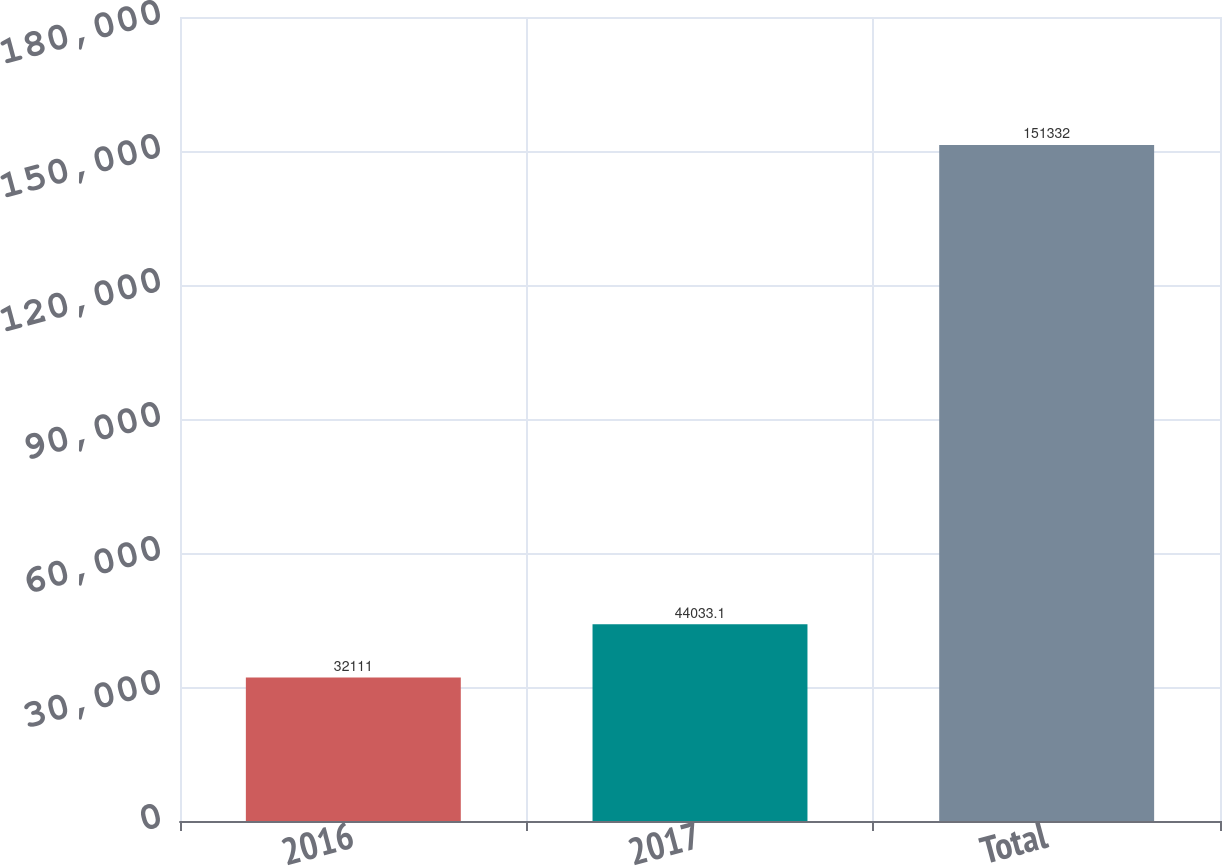<chart> <loc_0><loc_0><loc_500><loc_500><bar_chart><fcel>2016<fcel>2017<fcel>Total<nl><fcel>32111<fcel>44033.1<fcel>151332<nl></chart> 